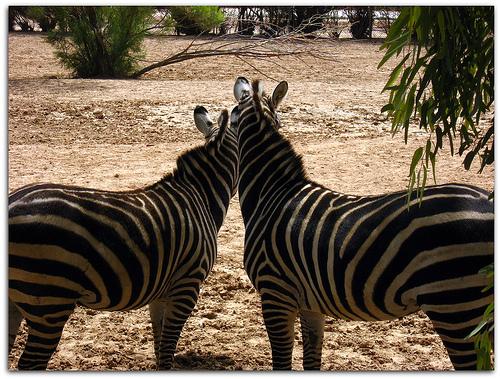Is there a grass?
Keep it brief. No. Are there trees in the picture?
Answer briefly. Yes. How many zebras are there?
Quick response, please. 2. 